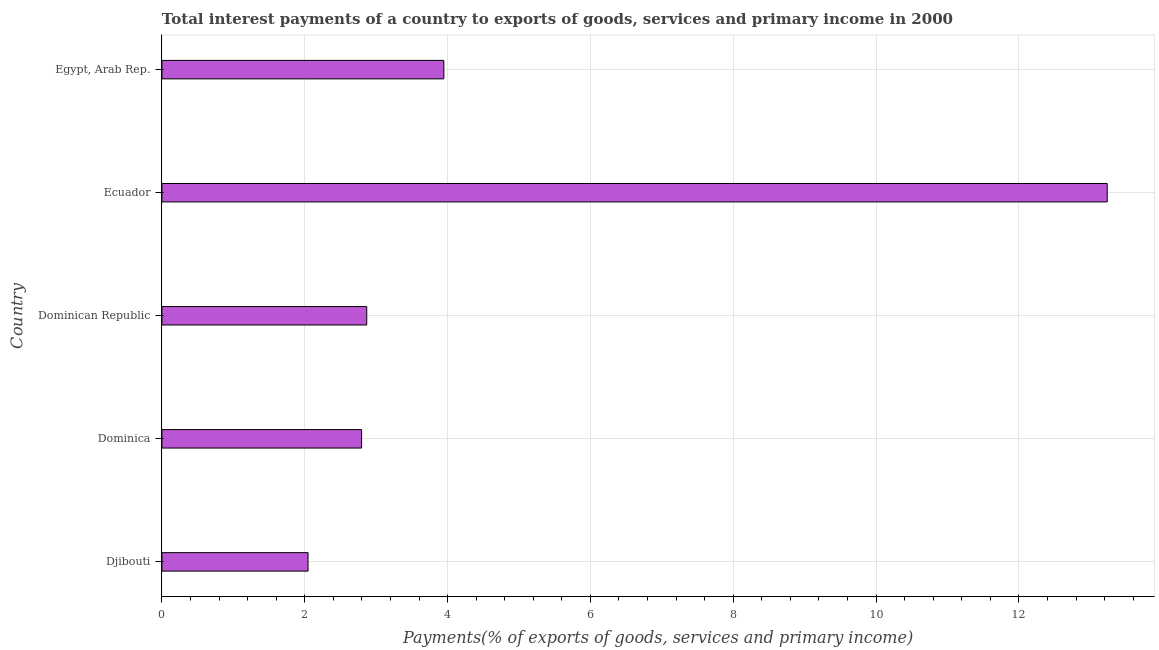Does the graph contain grids?
Provide a short and direct response. Yes. What is the title of the graph?
Provide a short and direct response. Total interest payments of a country to exports of goods, services and primary income in 2000. What is the label or title of the X-axis?
Give a very brief answer. Payments(% of exports of goods, services and primary income). What is the total interest payments on external debt in Dominican Republic?
Make the answer very short. 2.87. Across all countries, what is the maximum total interest payments on external debt?
Offer a very short reply. 13.24. Across all countries, what is the minimum total interest payments on external debt?
Offer a terse response. 2.05. In which country was the total interest payments on external debt maximum?
Ensure brevity in your answer.  Ecuador. In which country was the total interest payments on external debt minimum?
Make the answer very short. Djibouti. What is the sum of the total interest payments on external debt?
Offer a terse response. 24.89. What is the difference between the total interest payments on external debt in Ecuador and Egypt, Arab Rep.?
Keep it short and to the point. 9.29. What is the average total interest payments on external debt per country?
Your answer should be compact. 4.98. What is the median total interest payments on external debt?
Keep it short and to the point. 2.87. In how many countries, is the total interest payments on external debt greater than 5.2 %?
Provide a short and direct response. 1. What is the ratio of the total interest payments on external debt in Dominican Republic to that in Egypt, Arab Rep.?
Make the answer very short. 0.73. Is the total interest payments on external debt in Dominica less than that in Dominican Republic?
Provide a short and direct response. Yes. Is the difference between the total interest payments on external debt in Djibouti and Dominica greater than the difference between any two countries?
Your answer should be very brief. No. What is the difference between the highest and the second highest total interest payments on external debt?
Keep it short and to the point. 9.29. What is the difference between the highest and the lowest total interest payments on external debt?
Make the answer very short. 11.19. Are all the bars in the graph horizontal?
Provide a short and direct response. Yes. Are the values on the major ticks of X-axis written in scientific E-notation?
Your answer should be compact. No. What is the Payments(% of exports of goods, services and primary income) in Djibouti?
Your response must be concise. 2.05. What is the Payments(% of exports of goods, services and primary income) of Dominica?
Ensure brevity in your answer.  2.8. What is the Payments(% of exports of goods, services and primary income) of Dominican Republic?
Make the answer very short. 2.87. What is the Payments(% of exports of goods, services and primary income) of Ecuador?
Your answer should be compact. 13.24. What is the Payments(% of exports of goods, services and primary income) in Egypt, Arab Rep.?
Ensure brevity in your answer.  3.95. What is the difference between the Payments(% of exports of goods, services and primary income) in Djibouti and Dominica?
Offer a terse response. -0.75. What is the difference between the Payments(% of exports of goods, services and primary income) in Djibouti and Dominican Republic?
Give a very brief answer. -0.82. What is the difference between the Payments(% of exports of goods, services and primary income) in Djibouti and Ecuador?
Your response must be concise. -11.19. What is the difference between the Payments(% of exports of goods, services and primary income) in Djibouti and Egypt, Arab Rep.?
Offer a terse response. -1.9. What is the difference between the Payments(% of exports of goods, services and primary income) in Dominica and Dominican Republic?
Provide a succinct answer. -0.07. What is the difference between the Payments(% of exports of goods, services and primary income) in Dominica and Ecuador?
Your answer should be compact. -10.44. What is the difference between the Payments(% of exports of goods, services and primary income) in Dominica and Egypt, Arab Rep.?
Offer a very short reply. -1.15. What is the difference between the Payments(% of exports of goods, services and primary income) in Dominican Republic and Ecuador?
Offer a very short reply. -10.37. What is the difference between the Payments(% of exports of goods, services and primary income) in Dominican Republic and Egypt, Arab Rep.?
Ensure brevity in your answer.  -1.08. What is the difference between the Payments(% of exports of goods, services and primary income) in Ecuador and Egypt, Arab Rep.?
Your answer should be compact. 9.29. What is the ratio of the Payments(% of exports of goods, services and primary income) in Djibouti to that in Dominica?
Keep it short and to the point. 0.73. What is the ratio of the Payments(% of exports of goods, services and primary income) in Djibouti to that in Dominican Republic?
Provide a short and direct response. 0.71. What is the ratio of the Payments(% of exports of goods, services and primary income) in Djibouti to that in Ecuador?
Make the answer very short. 0.15. What is the ratio of the Payments(% of exports of goods, services and primary income) in Djibouti to that in Egypt, Arab Rep.?
Provide a succinct answer. 0.52. What is the ratio of the Payments(% of exports of goods, services and primary income) in Dominica to that in Dominican Republic?
Give a very brief answer. 0.97. What is the ratio of the Payments(% of exports of goods, services and primary income) in Dominica to that in Ecuador?
Keep it short and to the point. 0.21. What is the ratio of the Payments(% of exports of goods, services and primary income) in Dominica to that in Egypt, Arab Rep.?
Ensure brevity in your answer.  0.71. What is the ratio of the Payments(% of exports of goods, services and primary income) in Dominican Republic to that in Ecuador?
Your response must be concise. 0.22. What is the ratio of the Payments(% of exports of goods, services and primary income) in Dominican Republic to that in Egypt, Arab Rep.?
Give a very brief answer. 0.73. What is the ratio of the Payments(% of exports of goods, services and primary income) in Ecuador to that in Egypt, Arab Rep.?
Your answer should be compact. 3.35. 